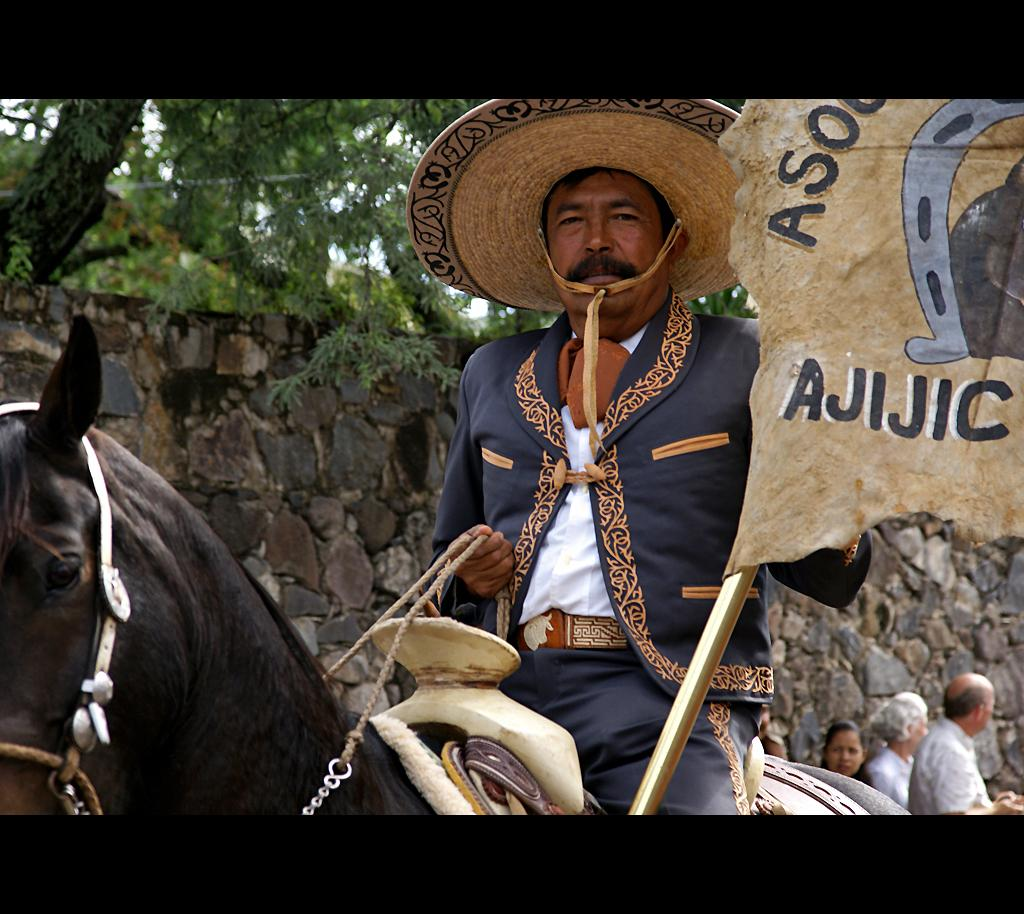What is the man in the image doing? The man is sitting on a horse in the image. What is the man wearing on his head? The man is wearing a hat. What can be seen in the image besides the man and the horse? There is a flag, ropes, and people in the image. What is visible in the background of the image? There is a wall and trees in the background of the image. What type of pan is being used for religious purposes in the image? There is no pan present in the image, and no religious practices are depicted. 